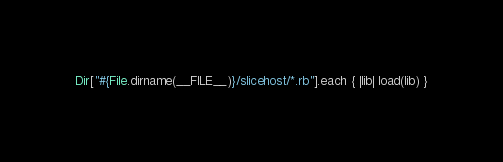<code> <loc_0><loc_0><loc_500><loc_500><_Ruby_>Dir["#{File.dirname(__FILE__)}/slicehost/*.rb"].each { |lib| load(lib) }
</code> 